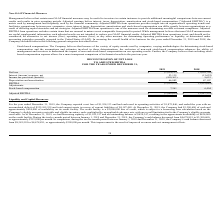According to Telkonet's financial document, What is adjusted EBITDA? Adjusted earnings before interest, taxes, depreciation, amortization and stock-based compensation. The document states: "t results and results in prior operating periods. Adjusted earnings before interest, taxes, depreciation, amortization and stock-based compensation (“..." Also, What is the adjusted EBITDA from operations used for? used for determining our debt covenant compliance. The document states: "ted EBITDA from operations is one of the measures used for determining our debt covenant compliance. Adjusted EBITDA from operations excludes certain ..." Also, What was the net loss reported for the year ended December 31, 2019? According to the financial document, $1,934,133. The relevant text states: "ember 31, 2019, the Company reported a net loss of $1,934,133 and had cash used in operating activities of $1,875,846, and ended the year with an accumulated defi..." Additionally, Which year has the higher stock-based compensation? According to the financial document, 2019. The relevant text states: "2019 2018..." Also, can you calculate: What is the percentage change in net loss from 2018 to 2019? To answer this question, I need to perform calculations using the financial data. The calculation is: (1,934,133-3,016,750)/3,016,750, which equals -35.89 (percentage). This is based on the information: "Net loss $ (1,934,133) $ (3,016,750) Net loss $ (1,934,133) $ (3,016,750)..." The key data points involved are: 1,934,133, 3,016,750. Also, can you calculate: What is the percentage change in the cash balance from January 1, 2019 to December 31, 2019? To answer this question, I need to perform calculations using the financial data. The calculation is: (3,300,600-4,678,891)/4,678,891, which equals -29.46 (percentage). This is based on the information: "2019, the Company’s cash balance decreased from $4,678,891 to $3,300,600, or approximately $115,000 per month. In comparison, during the twelve-month period b 2019, the Company’s cash balance decrease..." The key data points involved are: 3,300,600, 4,678,891. 